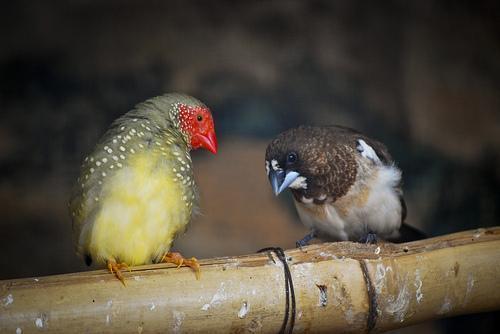How many birds?
Give a very brief answer. 2. How many birds have red beaks?
Give a very brief answer. 1. 